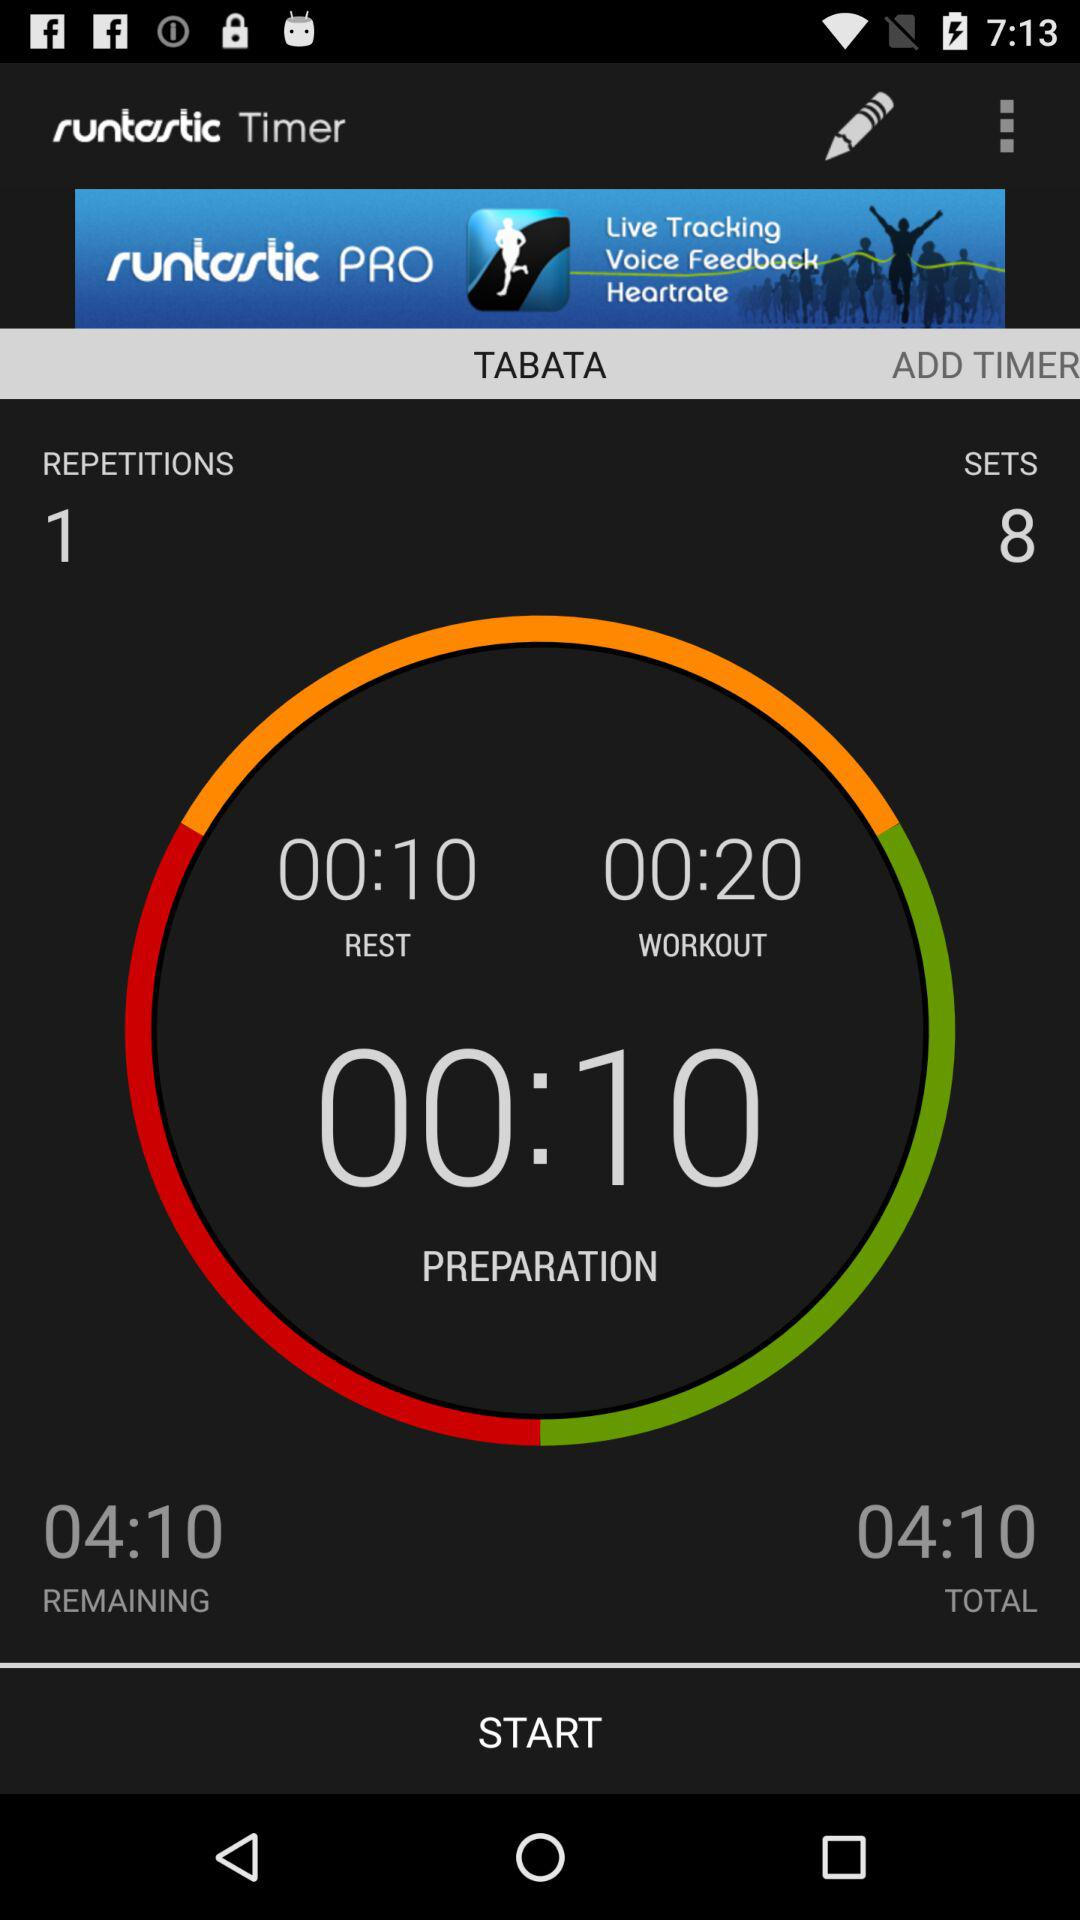What is the preparation duration? The preparation duration is 10 seconds. 